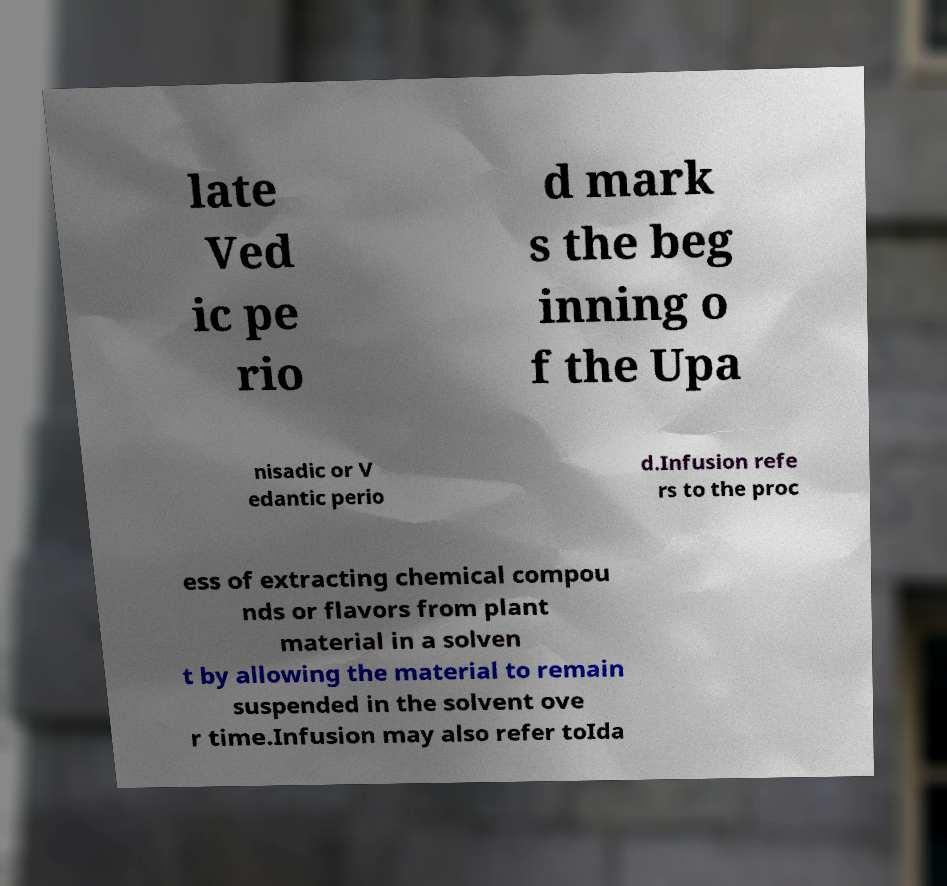There's text embedded in this image that I need extracted. Can you transcribe it verbatim? late Ved ic pe rio d mark s the beg inning o f the Upa nisadic or V edantic perio d.Infusion refe rs to the proc ess of extracting chemical compou nds or flavors from plant material in a solven t by allowing the material to remain suspended in the solvent ove r time.Infusion may also refer toIda 